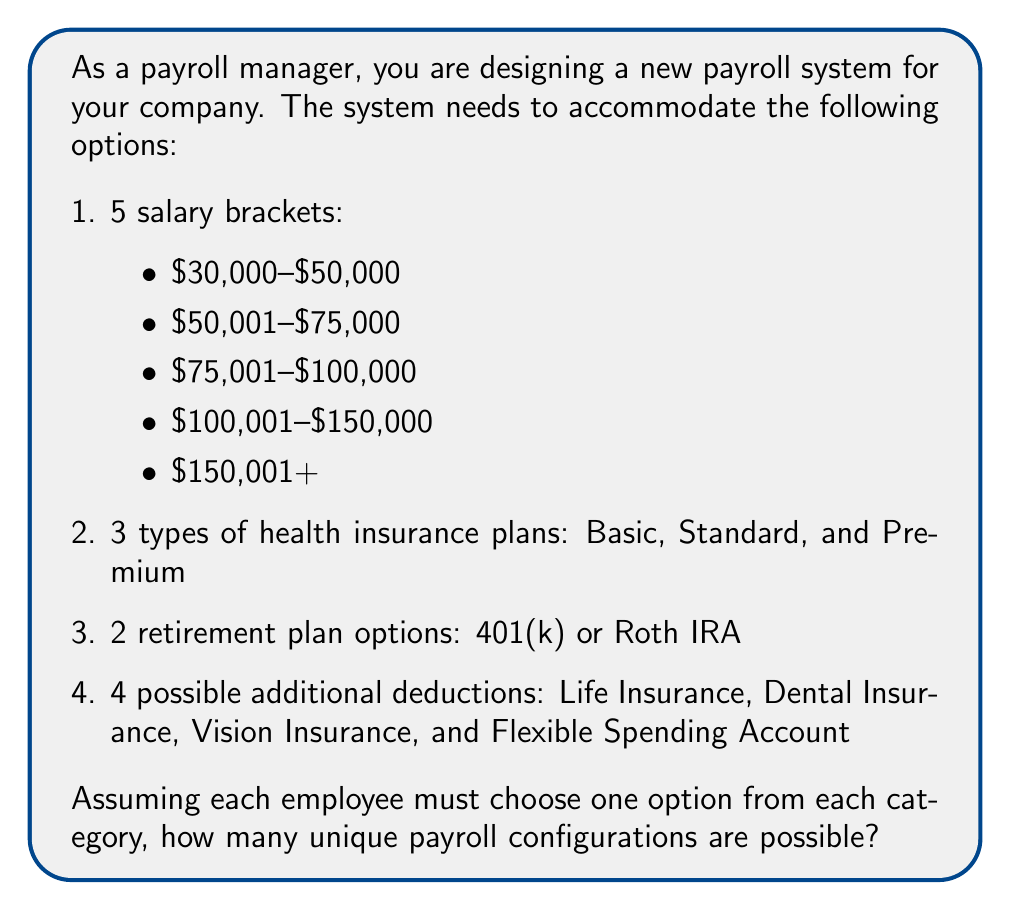Give your solution to this math problem. To solve this problem, we'll use the multiplication principle of combinatorics. This principle states that if we have a sequence of independent choices, the total number of possible outcomes is the product of the number of options for each choice.

Let's break down the choices:

1. Salary brackets: 5 options
2. Health insurance plans: 3 options
3. Retirement plan options: 2 options
4. Additional deductions: For each of the 4 deductions, an employee can either choose it or not. This creates 2 options for each deduction.

For the additional deductions, we need to calculate the number of possible combinations. Since each deduction is independent and can be chosen or not chosen, we have 2 options for each of the 4 deductions. This can be represented as $2^4$.

Now, let's multiply all these options together:

$$ \text{Total configurations} = 5 \times 3 \times 2 \times 2^4 $$

$$ = 5 \times 3 \times 2 \times 16 $$

$$ = 30 \times 16 $$

$$ = 480 $$

Therefore, there are 480 unique payroll configurations possible based on the given options.
Answer: 480 unique configurations 